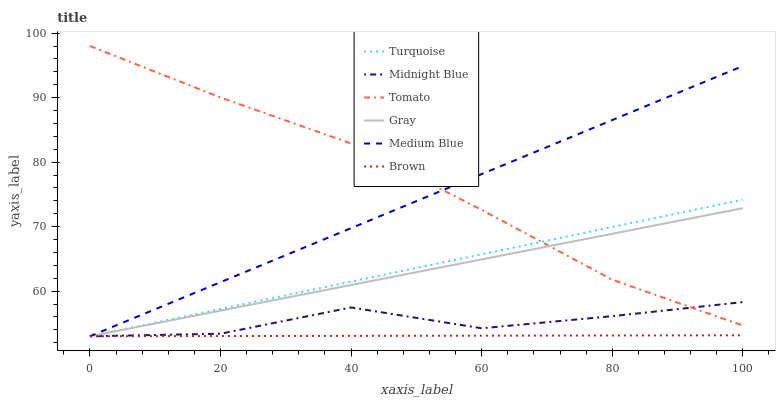Does Brown have the minimum area under the curve?
Answer yes or no. Yes. Does Tomato have the maximum area under the curve?
Answer yes or no. Yes. Does Gray have the minimum area under the curve?
Answer yes or no. No. Does Gray have the maximum area under the curve?
Answer yes or no. No. Is Turquoise the smoothest?
Answer yes or no. Yes. Is Midnight Blue the roughest?
Answer yes or no. Yes. Is Gray the smoothest?
Answer yes or no. No. Is Gray the roughest?
Answer yes or no. No. Does Gray have the lowest value?
Answer yes or no. Yes. Does Tomato have the highest value?
Answer yes or no. Yes. Does Gray have the highest value?
Answer yes or no. No. Is Brown less than Tomato?
Answer yes or no. Yes. Is Tomato greater than Brown?
Answer yes or no. Yes. Does Medium Blue intersect Gray?
Answer yes or no. Yes. Is Medium Blue less than Gray?
Answer yes or no. No. Is Medium Blue greater than Gray?
Answer yes or no. No. Does Brown intersect Tomato?
Answer yes or no. No. 